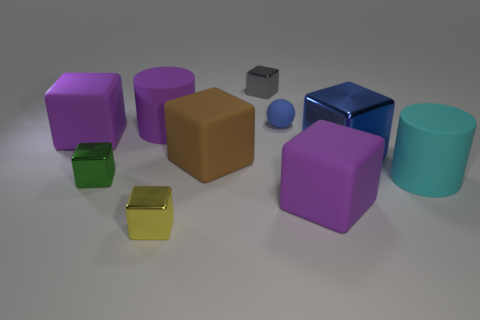Subtract 3 blocks. How many blocks are left? 4 Subtract all brown cubes. How many cubes are left? 6 Subtract all large brown matte cubes. How many cubes are left? 6 Subtract all green blocks. Subtract all gray balls. How many blocks are left? 6 Subtract all balls. How many objects are left? 9 Subtract 0 red cylinders. How many objects are left? 10 Subtract all large gray metallic objects. Subtract all big matte cylinders. How many objects are left? 8 Add 3 yellow metallic things. How many yellow metallic things are left? 4 Add 7 small metal cylinders. How many small metal cylinders exist? 7 